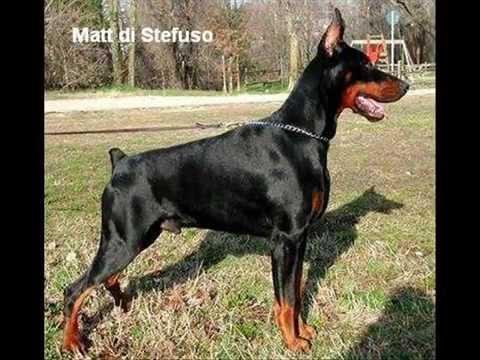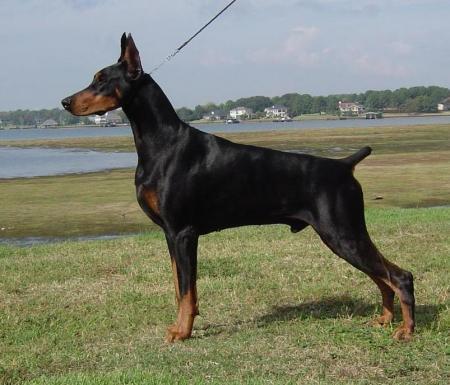The first image is the image on the left, the second image is the image on the right. For the images shown, is this caption "Two dobermans can be seen standing at attention while outside." true? Answer yes or no. Yes. The first image is the image on the left, the second image is the image on the right. Given the left and right images, does the statement "The left image contains one dog facing towards the left." hold true? Answer yes or no. No. 